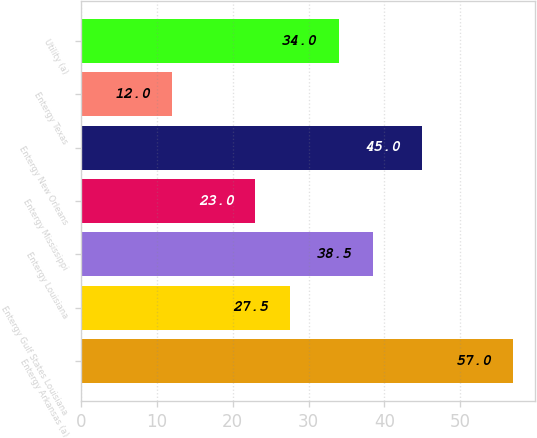<chart> <loc_0><loc_0><loc_500><loc_500><bar_chart><fcel>Entergy Arkansas (a)<fcel>Entergy Gulf States Louisiana<fcel>Entergy Louisiana<fcel>Entergy Mississippi<fcel>Entergy New Orleans<fcel>Entergy Texas<fcel>Utility (a)<nl><fcel>57<fcel>27.5<fcel>38.5<fcel>23<fcel>45<fcel>12<fcel>34<nl></chart> 